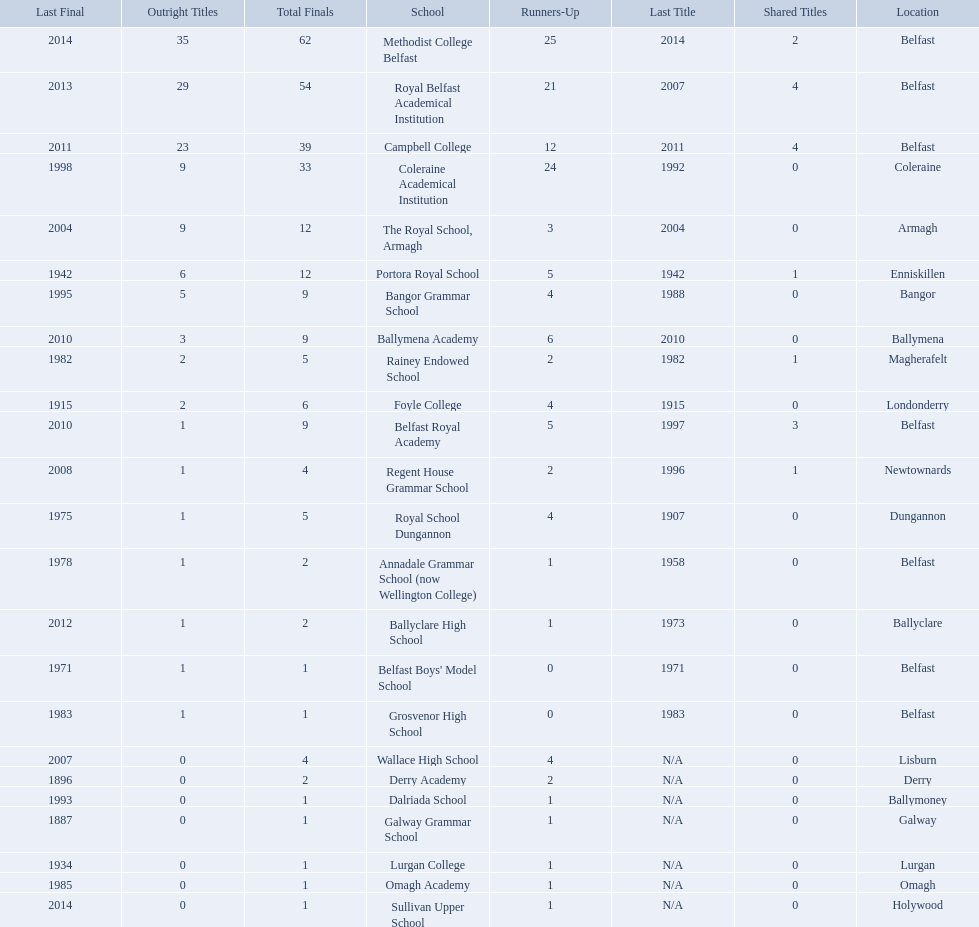What is the most recent win of campbell college? 2011. What is the most recent win of regent house grammar school? 1996. Which date is more recent? 2011. What is the name of the school with this date? Campbell College. 